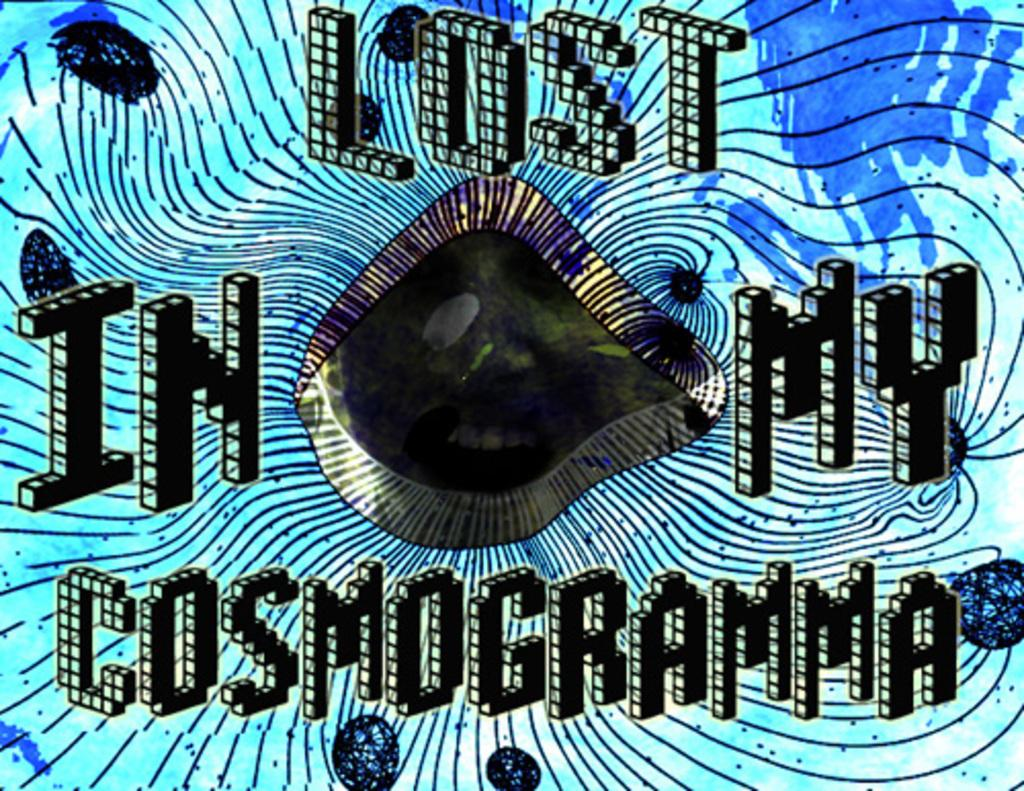Provide a one-sentence caption for the provided image. The unidentifiable face peers out from a blue and black graphic proclaiming, "Lost in my cosmogramma.". 